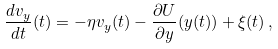<formula> <loc_0><loc_0><loc_500><loc_500>\frac { d v _ { y } } { d t } ( t ) = - \eta v _ { y } ( t ) - \frac { \partial U } { \partial y } ( y ( t ) ) + \xi ( t ) \, ,</formula> 